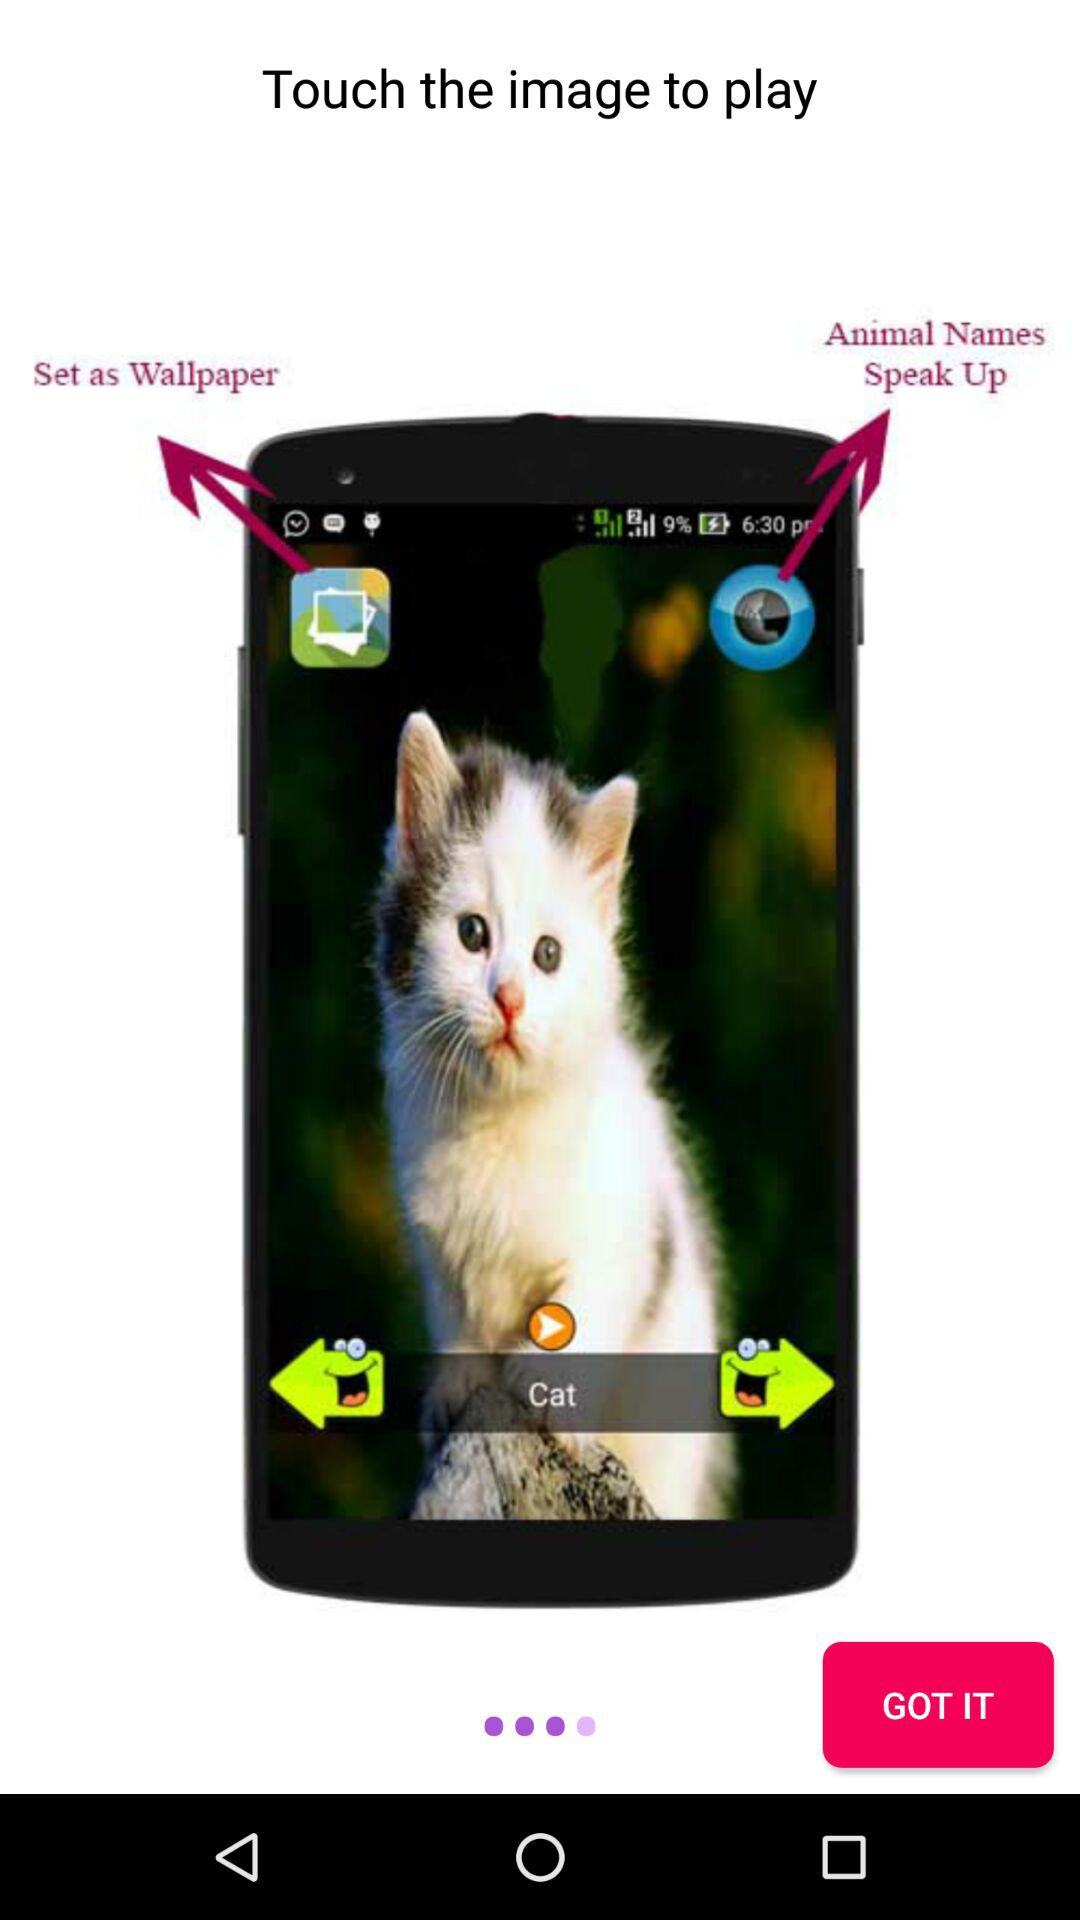How to play? To Play touch the image. 